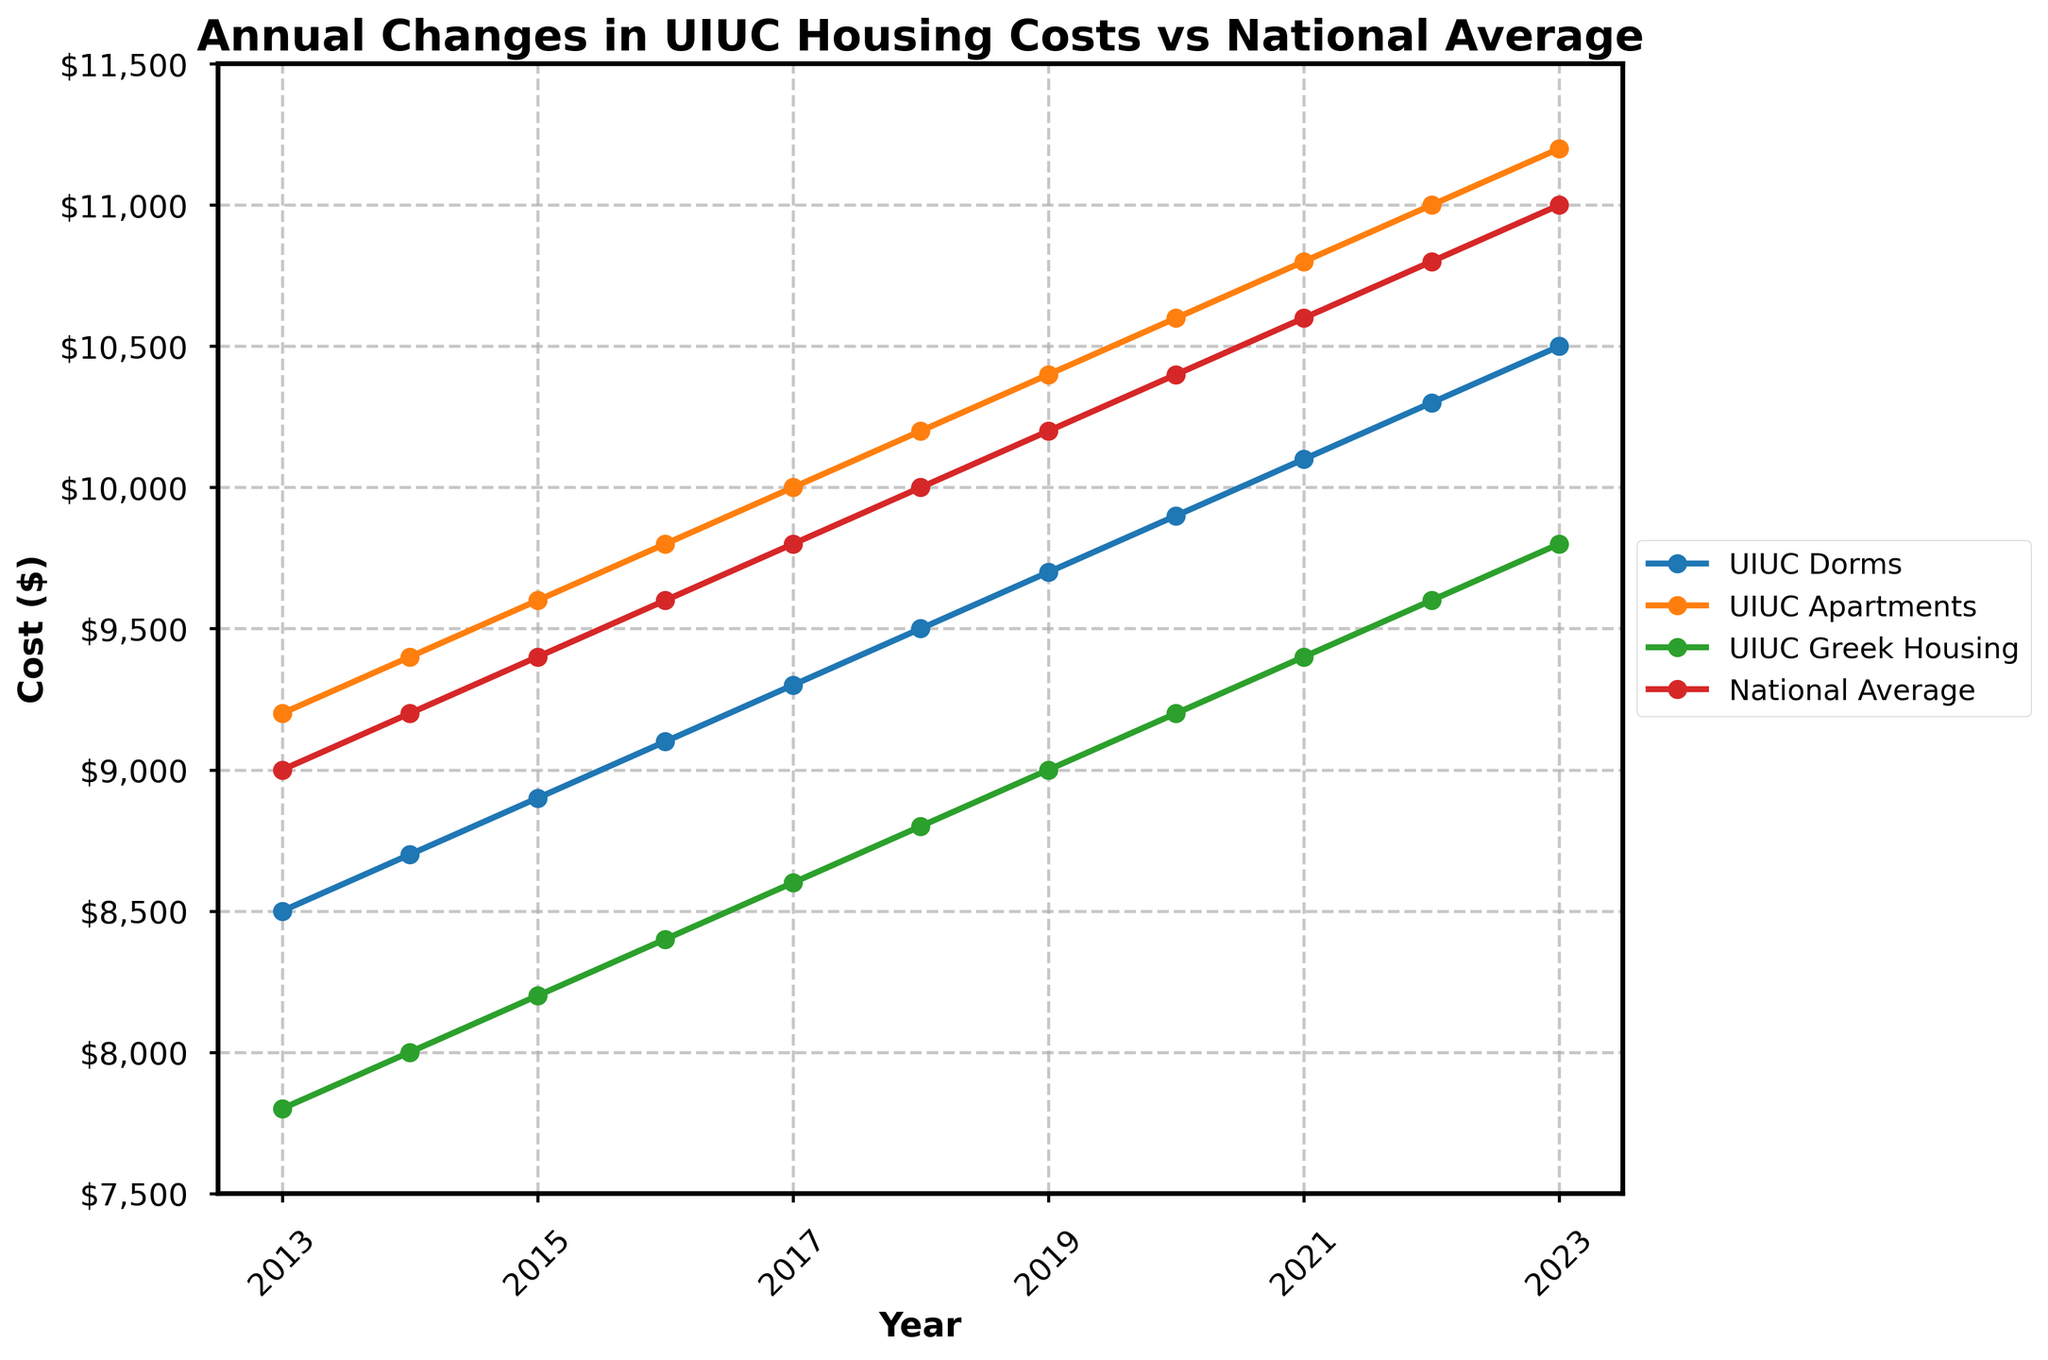What is the cost difference between UIUC Greek Housing and the National Average in 2013? In 2013, the cost for UIUC Greek Housing was $7,800, and the National Average was $9,000. Subtract the UIUC Greek Housing cost from the National Average: $9,000 - $7,800 = $1,200.
Answer: $1,200 How much did UIUC Dorms' costs increase from 2013 to 2023? In 2013, UIUC Dorms cost $8,500, and in 2023, they cost $10,500. Subtract the 2013 cost from the 2023 cost: $10,500 - $8,500 = $2,000.
Answer: $2,000 Which accommodation type had the highest cost in 2016? In 2016, among UIUC Dorms ($9,100), UIUC Apartments ($9,800), UIUC Greek Housing ($8,400), and the National Average ($9,600), UIUC Apartments had the highest cost.
Answer: UIUC Apartments Did the costs for UIUC Apartments ever drop between 2013 and 2023? Examining the trend line for UIUC Apartments from 2013 to 2023, the line consistently shows an upward trend with no drops in any year.
Answer: No What is the average cost of UIUC Dorms from 2013 to 2023? The costs for UIUC Dorms from 2013 to 2023 were $8,500, $8,700, $8,900, $9,100, $9,300, $9,500, $9,700, $9,900, $10,100, $10,300, and $10,500. Sum these values: $8,500 + $8,700 + $8,900 + $9,100 + $9,300 + $9,500 + $9,700 + $9,900 + $10,100 + $10,300 + $10,500 = $104,500. Divide by 11 (number of years): $104,500 / 11 = $9,500.
Answer: $9,500 Which year had the largest increase in National Average costs compared to the previous year? Calculate the yearly increase: 2014 ($9,200 - $9,000 = $200), 2015 ($9,400 - $9,200 = $200), 2016 ($9,600 - $9,400 = $200), 2017 ($9,800 - $9,600 = $200), 2018 ($10,000 - $9,800 = $200), 2019 ($10,200 - $10,000 = $200), 2020 ($10,400 - $10,200 = $200), 2021 ($10,600 - $10,400 = $200), 2022 ($10,800 - $10,600 = $200), 2023 ($11,000 - $10,800 = $200). All increases are the same.
Answer: All years Which accommodation types crossed the $10,000 mark first, and in which year? UIUC Apartments reached $10,000 in 2017, and the National Average also crossed $10,000 in 2018.
Answer: UIUC Apartments, 2017 How much more did UIUC Greek Housing cost in 2020 compared to 2013? In 2020, UIUC Greek Housing cost $9,200, and in 2013, it cost $7,800. Subtract the 2013 cost from 2020: $9,200 - $7,800 = $1,400.
Answer: $1,400 